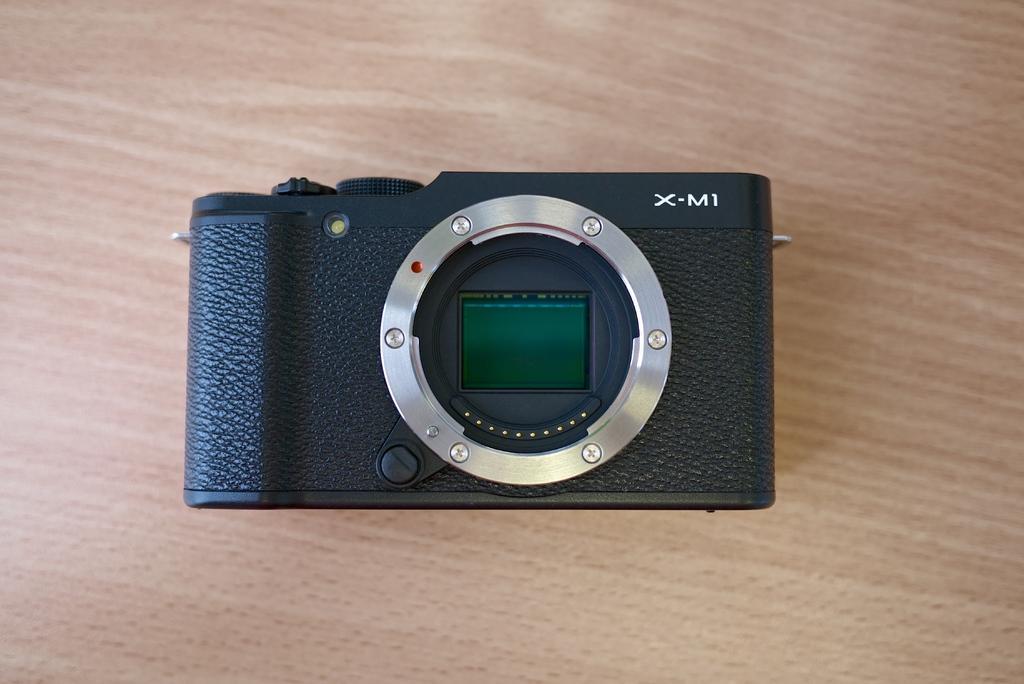Can you describe this image briefly? In this picture, we see the camera is placed on the wooden table. This camera is in black color. 